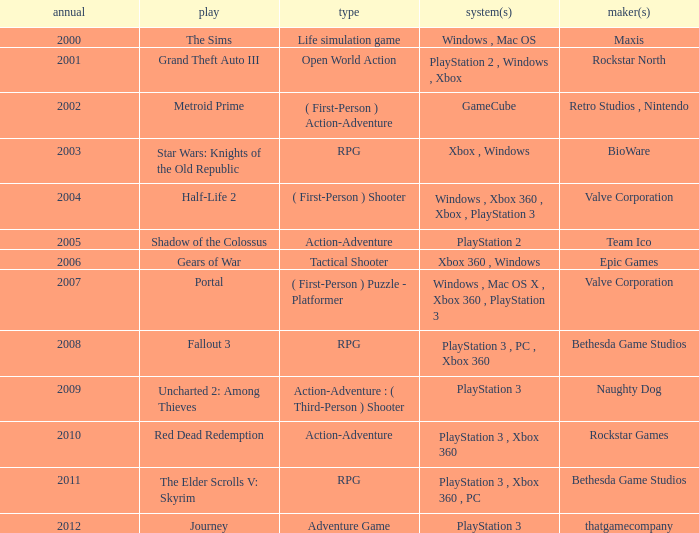What game was in 2011? The Elder Scrolls V: Skyrim. 